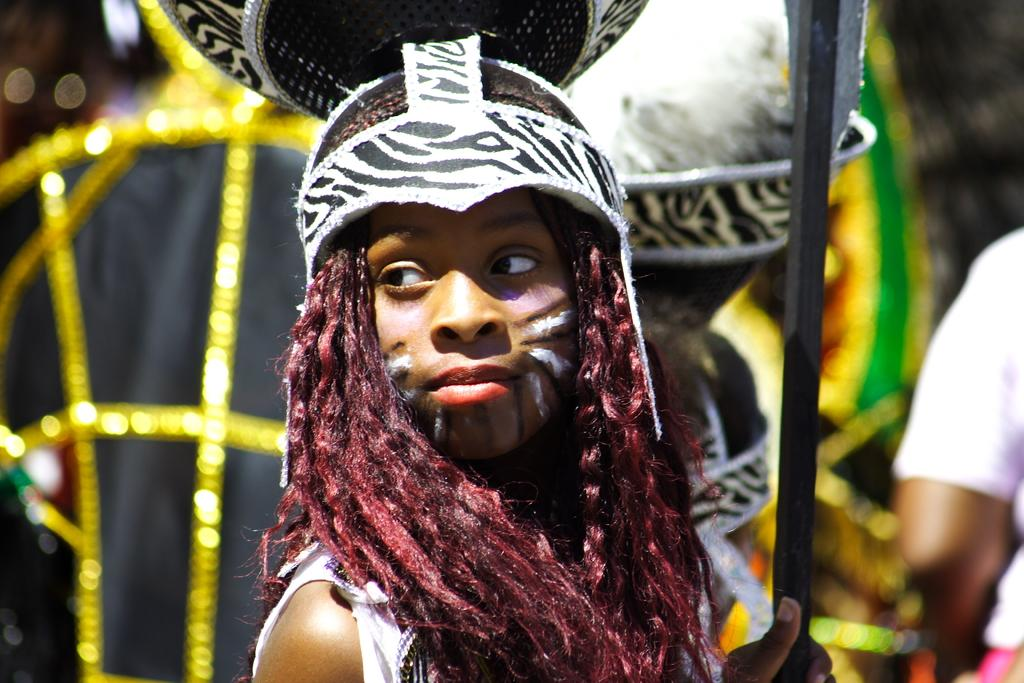What is the person in the image wearing? The person in the image is wearing a costume. What is the person holding in the image? The person is holding a rod. Can you describe the background of the image? The background of the image is blurry. Are there any other people visible in the image? Yes, there are people visible in the background of the image. How many sheep and pigs are visible in the image? There are no sheep or pigs present in the image. 